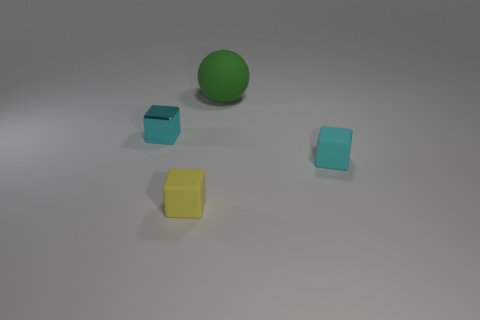Is there a tiny rubber thing of the same color as the small metal thing? Yes, there is a small yellow rubber object that appears to be the same color as the small metal object. 